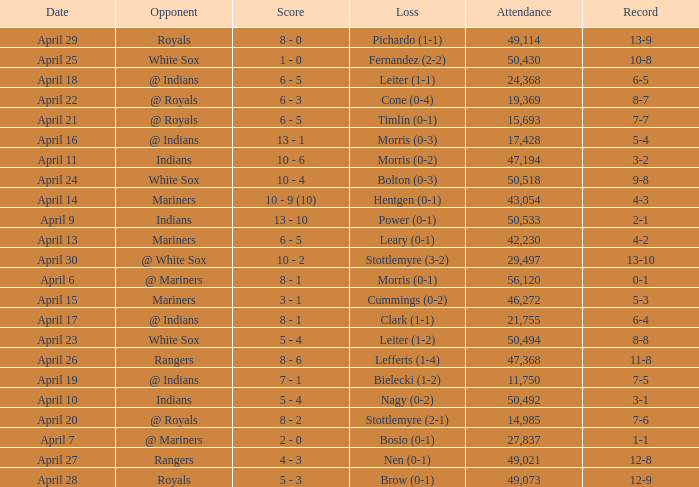What scored is recorded on April 24? 10 - 4. 